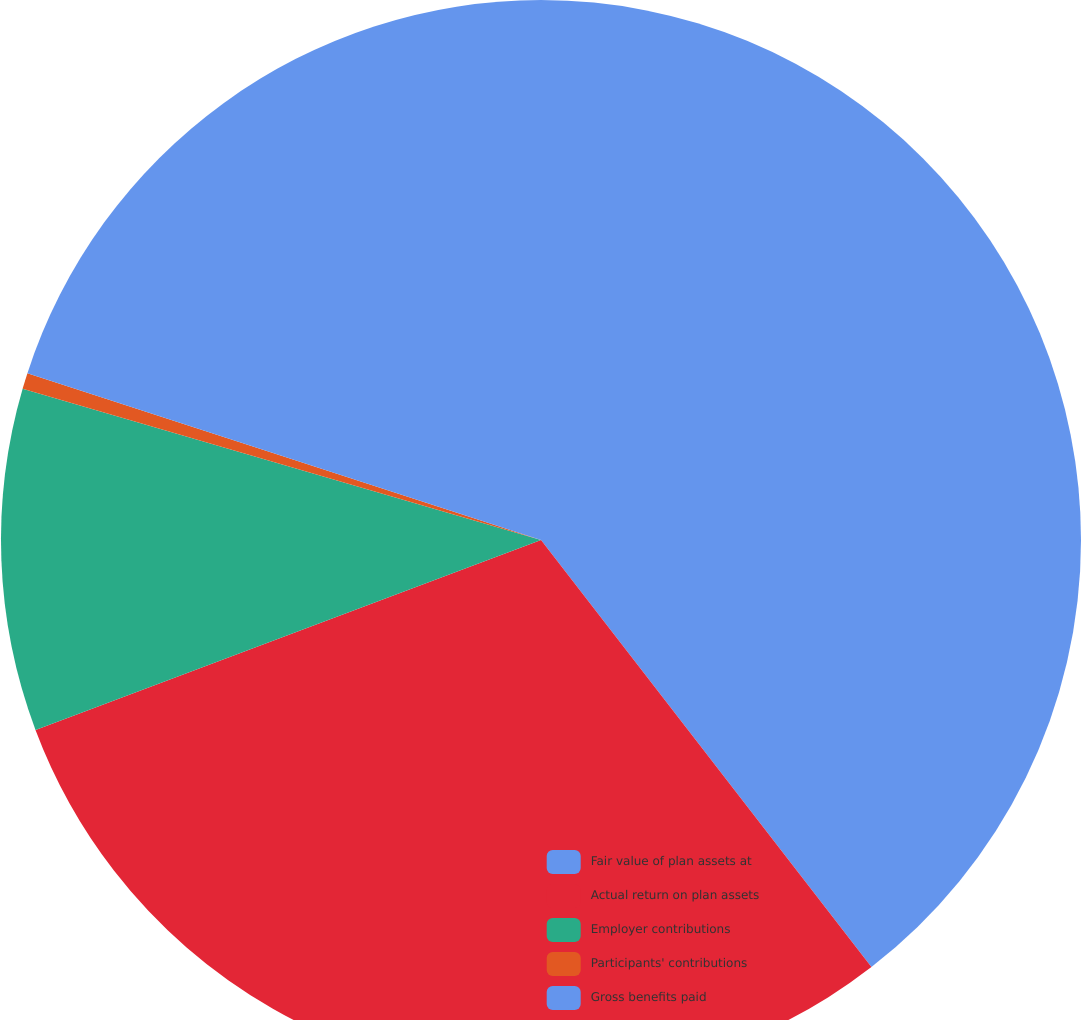Convert chart. <chart><loc_0><loc_0><loc_500><loc_500><pie_chart><fcel>Fair value of plan assets at<fcel>Actual return on plan assets<fcel>Employer contributions<fcel>Participants' contributions<fcel>Gross benefits paid<nl><fcel>39.52%<fcel>29.76%<fcel>10.24%<fcel>0.48%<fcel>20.0%<nl></chart> 